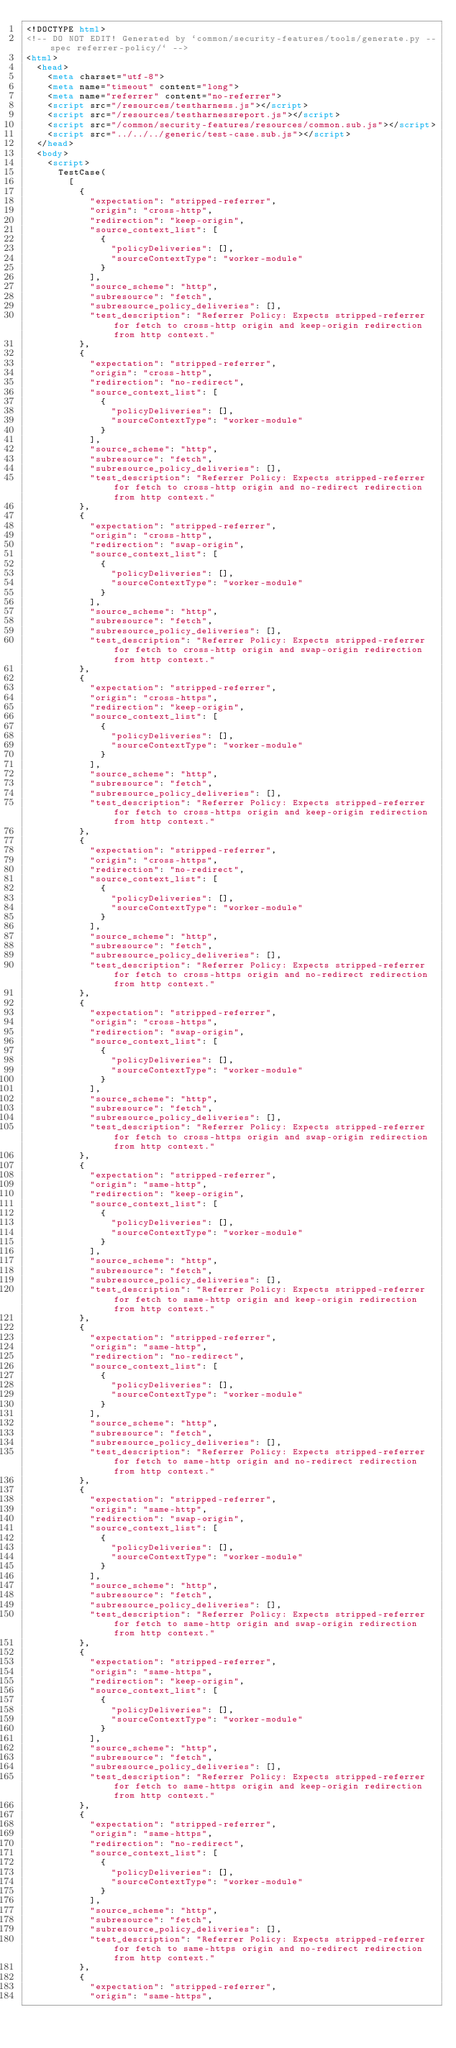<code> <loc_0><loc_0><loc_500><loc_500><_HTML_><!DOCTYPE html>
<!-- DO NOT EDIT! Generated by `common/security-features/tools/generate.py --spec referrer-policy/` -->
<html>
  <head>
    <meta charset="utf-8">
    <meta name="timeout" content="long">
    <meta name="referrer" content="no-referrer">
    <script src="/resources/testharness.js"></script>
    <script src="/resources/testharnessreport.js"></script>
    <script src="/common/security-features/resources/common.sub.js"></script>
    <script src="../../../generic/test-case.sub.js"></script>
  </head>
  <body>
    <script>
      TestCase(
        [
          {
            "expectation": "stripped-referrer",
            "origin": "cross-http",
            "redirection": "keep-origin",
            "source_context_list": [
              {
                "policyDeliveries": [],
                "sourceContextType": "worker-module"
              }
            ],
            "source_scheme": "http",
            "subresource": "fetch",
            "subresource_policy_deliveries": [],
            "test_description": "Referrer Policy: Expects stripped-referrer for fetch to cross-http origin and keep-origin redirection from http context."
          },
          {
            "expectation": "stripped-referrer",
            "origin": "cross-http",
            "redirection": "no-redirect",
            "source_context_list": [
              {
                "policyDeliveries": [],
                "sourceContextType": "worker-module"
              }
            ],
            "source_scheme": "http",
            "subresource": "fetch",
            "subresource_policy_deliveries": [],
            "test_description": "Referrer Policy: Expects stripped-referrer for fetch to cross-http origin and no-redirect redirection from http context."
          },
          {
            "expectation": "stripped-referrer",
            "origin": "cross-http",
            "redirection": "swap-origin",
            "source_context_list": [
              {
                "policyDeliveries": [],
                "sourceContextType": "worker-module"
              }
            ],
            "source_scheme": "http",
            "subresource": "fetch",
            "subresource_policy_deliveries": [],
            "test_description": "Referrer Policy: Expects stripped-referrer for fetch to cross-http origin and swap-origin redirection from http context."
          },
          {
            "expectation": "stripped-referrer",
            "origin": "cross-https",
            "redirection": "keep-origin",
            "source_context_list": [
              {
                "policyDeliveries": [],
                "sourceContextType": "worker-module"
              }
            ],
            "source_scheme": "http",
            "subresource": "fetch",
            "subresource_policy_deliveries": [],
            "test_description": "Referrer Policy: Expects stripped-referrer for fetch to cross-https origin and keep-origin redirection from http context."
          },
          {
            "expectation": "stripped-referrer",
            "origin": "cross-https",
            "redirection": "no-redirect",
            "source_context_list": [
              {
                "policyDeliveries": [],
                "sourceContextType": "worker-module"
              }
            ],
            "source_scheme": "http",
            "subresource": "fetch",
            "subresource_policy_deliveries": [],
            "test_description": "Referrer Policy: Expects stripped-referrer for fetch to cross-https origin and no-redirect redirection from http context."
          },
          {
            "expectation": "stripped-referrer",
            "origin": "cross-https",
            "redirection": "swap-origin",
            "source_context_list": [
              {
                "policyDeliveries": [],
                "sourceContextType": "worker-module"
              }
            ],
            "source_scheme": "http",
            "subresource": "fetch",
            "subresource_policy_deliveries": [],
            "test_description": "Referrer Policy: Expects stripped-referrer for fetch to cross-https origin and swap-origin redirection from http context."
          },
          {
            "expectation": "stripped-referrer",
            "origin": "same-http",
            "redirection": "keep-origin",
            "source_context_list": [
              {
                "policyDeliveries": [],
                "sourceContextType": "worker-module"
              }
            ],
            "source_scheme": "http",
            "subresource": "fetch",
            "subresource_policy_deliveries": [],
            "test_description": "Referrer Policy: Expects stripped-referrer for fetch to same-http origin and keep-origin redirection from http context."
          },
          {
            "expectation": "stripped-referrer",
            "origin": "same-http",
            "redirection": "no-redirect",
            "source_context_list": [
              {
                "policyDeliveries": [],
                "sourceContextType": "worker-module"
              }
            ],
            "source_scheme": "http",
            "subresource": "fetch",
            "subresource_policy_deliveries": [],
            "test_description": "Referrer Policy: Expects stripped-referrer for fetch to same-http origin and no-redirect redirection from http context."
          },
          {
            "expectation": "stripped-referrer",
            "origin": "same-http",
            "redirection": "swap-origin",
            "source_context_list": [
              {
                "policyDeliveries": [],
                "sourceContextType": "worker-module"
              }
            ],
            "source_scheme": "http",
            "subresource": "fetch",
            "subresource_policy_deliveries": [],
            "test_description": "Referrer Policy: Expects stripped-referrer for fetch to same-http origin and swap-origin redirection from http context."
          },
          {
            "expectation": "stripped-referrer",
            "origin": "same-https",
            "redirection": "keep-origin",
            "source_context_list": [
              {
                "policyDeliveries": [],
                "sourceContextType": "worker-module"
              }
            ],
            "source_scheme": "http",
            "subresource": "fetch",
            "subresource_policy_deliveries": [],
            "test_description": "Referrer Policy: Expects stripped-referrer for fetch to same-https origin and keep-origin redirection from http context."
          },
          {
            "expectation": "stripped-referrer",
            "origin": "same-https",
            "redirection": "no-redirect",
            "source_context_list": [
              {
                "policyDeliveries": [],
                "sourceContextType": "worker-module"
              }
            ],
            "source_scheme": "http",
            "subresource": "fetch",
            "subresource_policy_deliveries": [],
            "test_description": "Referrer Policy: Expects stripped-referrer for fetch to same-https origin and no-redirect redirection from http context."
          },
          {
            "expectation": "stripped-referrer",
            "origin": "same-https",</code> 